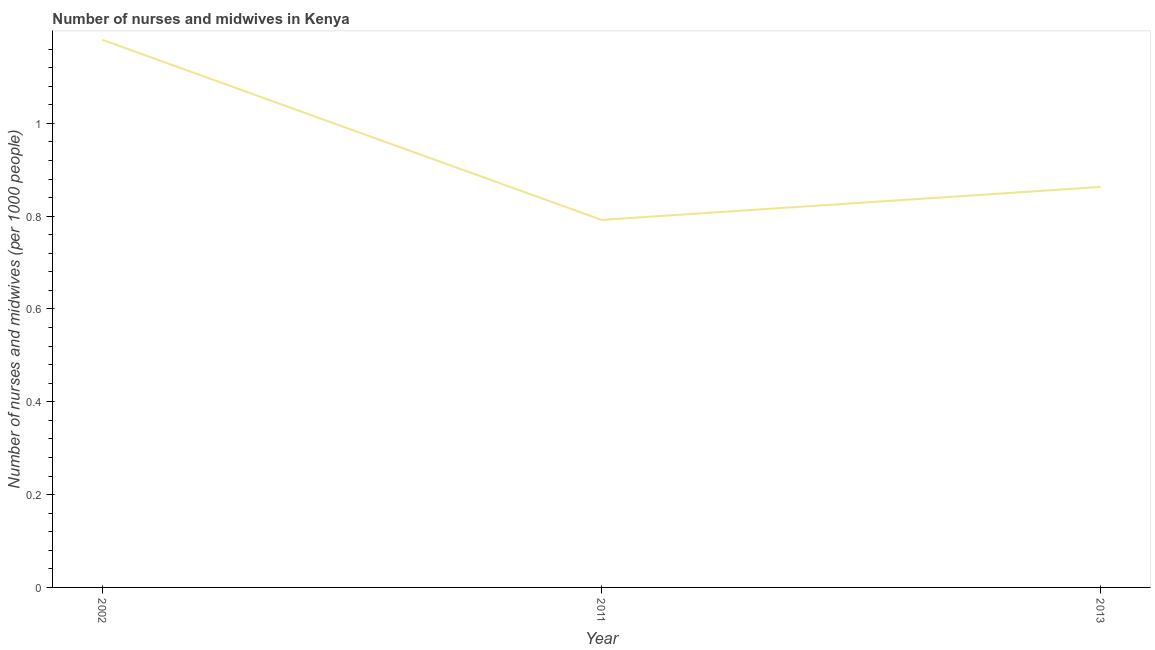What is the number of nurses and midwives in 2002?
Your response must be concise. 1.18. Across all years, what is the maximum number of nurses and midwives?
Your answer should be compact. 1.18. Across all years, what is the minimum number of nurses and midwives?
Your answer should be compact. 0.79. In which year was the number of nurses and midwives maximum?
Provide a succinct answer. 2002. In which year was the number of nurses and midwives minimum?
Give a very brief answer. 2011. What is the sum of the number of nurses and midwives?
Your answer should be very brief. 2.83. What is the difference between the number of nurses and midwives in 2002 and 2013?
Your response must be concise. 0.32. What is the average number of nurses and midwives per year?
Your answer should be compact. 0.94. What is the median number of nurses and midwives?
Make the answer very short. 0.86. What is the ratio of the number of nurses and midwives in 2002 to that in 2013?
Your response must be concise. 1.37. Is the number of nurses and midwives in 2002 less than that in 2013?
Ensure brevity in your answer.  No. Is the difference between the number of nurses and midwives in 2002 and 2011 greater than the difference between any two years?
Offer a very short reply. Yes. What is the difference between the highest and the second highest number of nurses and midwives?
Provide a short and direct response. 0.32. What is the difference between the highest and the lowest number of nurses and midwives?
Keep it short and to the point. 0.39. Does the number of nurses and midwives monotonically increase over the years?
Provide a short and direct response. No. What is the difference between two consecutive major ticks on the Y-axis?
Offer a very short reply. 0.2. What is the title of the graph?
Offer a terse response. Number of nurses and midwives in Kenya. What is the label or title of the X-axis?
Your response must be concise. Year. What is the label or title of the Y-axis?
Your answer should be compact. Number of nurses and midwives (per 1000 people). What is the Number of nurses and midwives (per 1000 people) in 2002?
Your answer should be very brief. 1.18. What is the Number of nurses and midwives (per 1000 people) of 2011?
Provide a short and direct response. 0.79. What is the Number of nurses and midwives (per 1000 people) of 2013?
Provide a succinct answer. 0.86. What is the difference between the Number of nurses and midwives (per 1000 people) in 2002 and 2011?
Your answer should be compact. 0.39. What is the difference between the Number of nurses and midwives (per 1000 people) in 2002 and 2013?
Your answer should be very brief. 0.32. What is the difference between the Number of nurses and midwives (per 1000 people) in 2011 and 2013?
Ensure brevity in your answer.  -0.07. What is the ratio of the Number of nurses and midwives (per 1000 people) in 2002 to that in 2011?
Make the answer very short. 1.49. What is the ratio of the Number of nurses and midwives (per 1000 people) in 2002 to that in 2013?
Make the answer very short. 1.37. What is the ratio of the Number of nurses and midwives (per 1000 people) in 2011 to that in 2013?
Give a very brief answer. 0.92. 